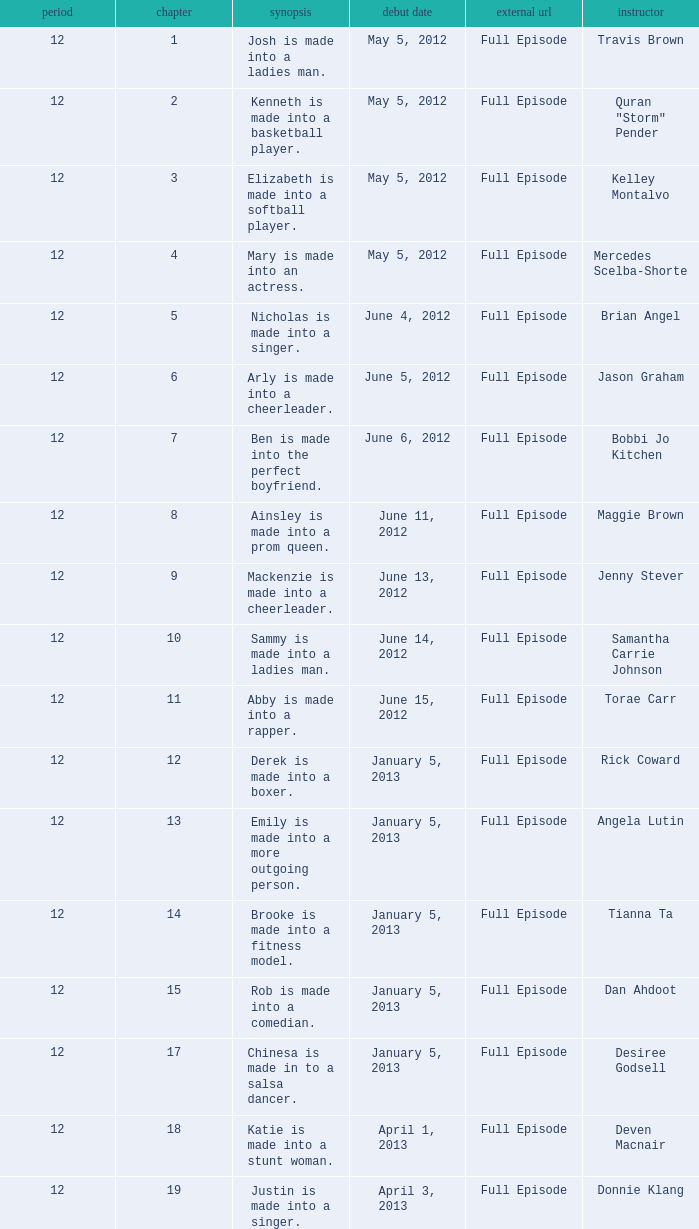Name the least episode for donnie klang 19.0. Could you parse the entire table? {'header': ['period', 'chapter', 'synopsis', 'debut date', 'external url', 'instructor'], 'rows': [['12', '1', 'Josh is made into a ladies man.', 'May 5, 2012', 'Full Episode', 'Travis Brown'], ['12', '2', 'Kenneth is made into a basketball player.', 'May 5, 2012', 'Full Episode', 'Quran "Storm" Pender'], ['12', '3', 'Elizabeth is made into a softball player.', 'May 5, 2012', 'Full Episode', 'Kelley Montalvo'], ['12', '4', 'Mary is made into an actress.', 'May 5, 2012', 'Full Episode', 'Mercedes Scelba-Shorte'], ['12', '5', 'Nicholas is made into a singer.', 'June 4, 2012', 'Full Episode', 'Brian Angel'], ['12', '6', 'Arly is made into a cheerleader.', 'June 5, 2012', 'Full Episode', 'Jason Graham'], ['12', '7', 'Ben is made into the perfect boyfriend.', 'June 6, 2012', 'Full Episode', 'Bobbi Jo Kitchen'], ['12', '8', 'Ainsley is made into a prom queen.', 'June 11, 2012', 'Full Episode', 'Maggie Brown'], ['12', '9', 'Mackenzie is made into a cheerleader.', 'June 13, 2012', 'Full Episode', 'Jenny Stever'], ['12', '10', 'Sammy is made into a ladies man.', 'June 14, 2012', 'Full Episode', 'Samantha Carrie Johnson'], ['12', '11', 'Abby is made into a rapper.', 'June 15, 2012', 'Full Episode', 'Torae Carr'], ['12', '12', 'Derek is made into a boxer.', 'January 5, 2013', 'Full Episode', 'Rick Coward'], ['12', '13', 'Emily is made into a more outgoing person.', 'January 5, 2013', 'Full Episode', 'Angela Lutin'], ['12', '14', 'Brooke is made into a fitness model.', 'January 5, 2013', 'Full Episode', 'Tianna Ta'], ['12', '15', 'Rob is made into a comedian.', 'January 5, 2013', 'Full Episode', 'Dan Ahdoot'], ['12', '17', 'Chinesa is made in to a salsa dancer.', 'January 5, 2013', 'Full Episode', 'Desiree Godsell'], ['12', '18', 'Katie is made into a stunt woman.', 'April 1, 2013', 'Full Episode', 'Deven Macnair'], ['12', '19', 'Justin is made into a singer.', 'April 3, 2013', 'Full Episode', 'Donnie Klang']]} 